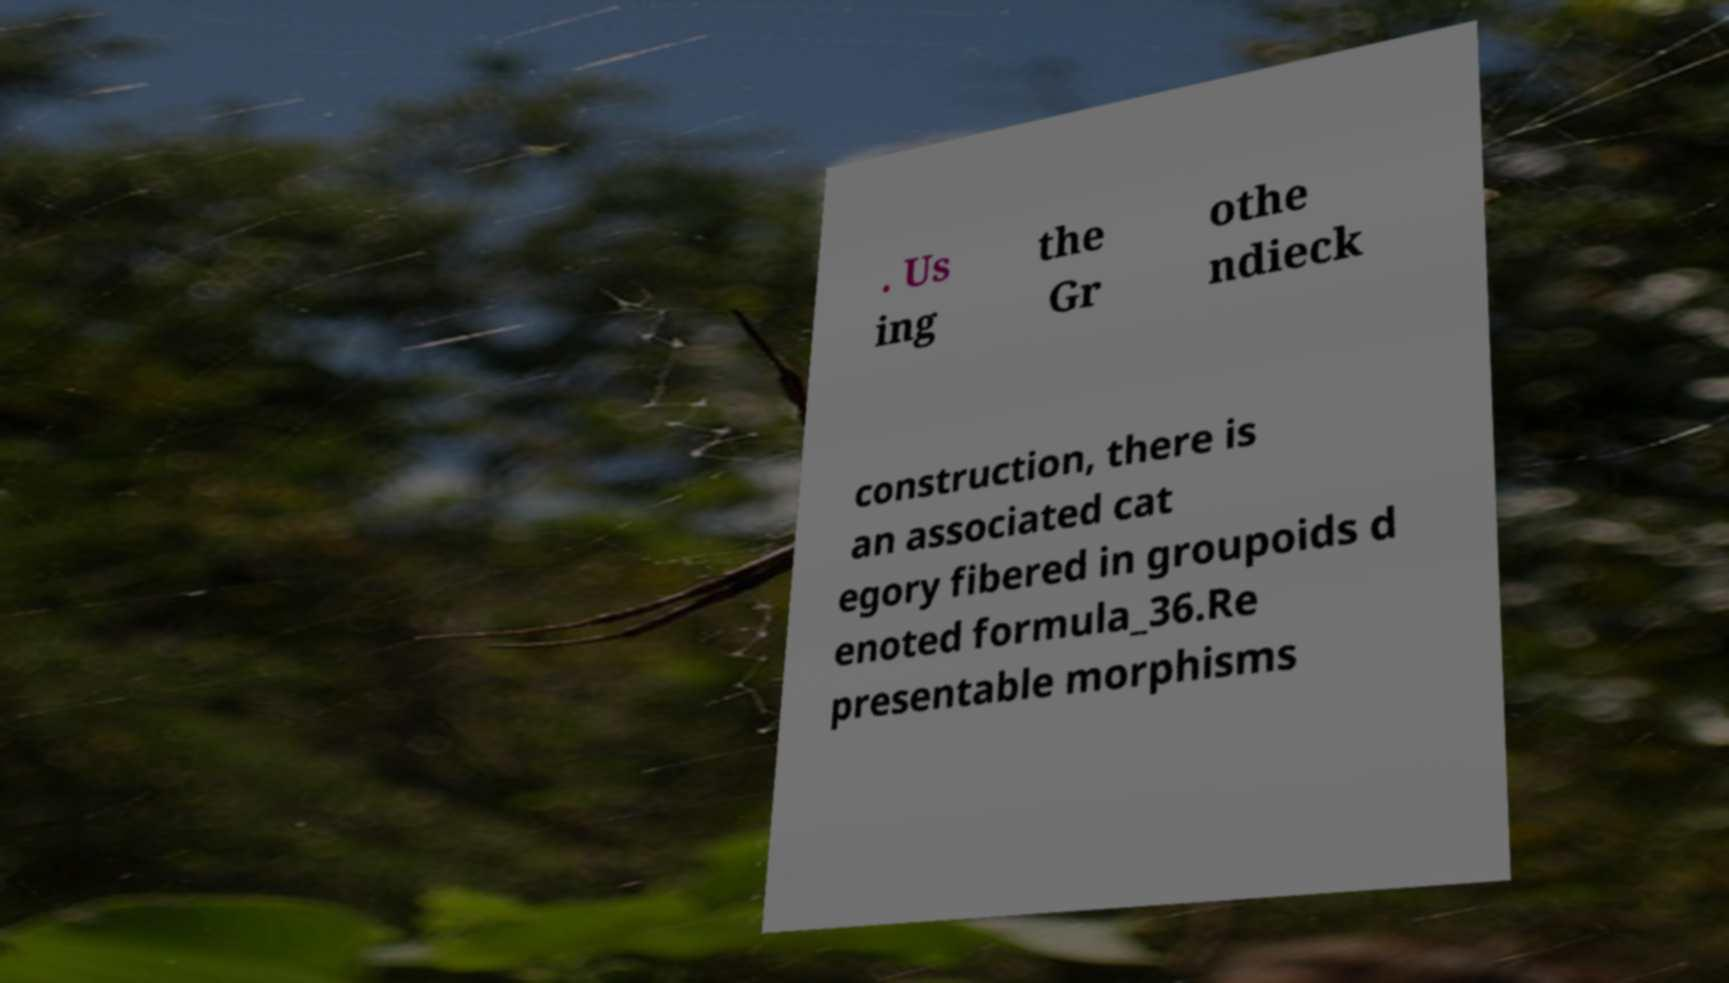Can you accurately transcribe the text from the provided image for me? . Us ing the Gr othe ndieck construction, there is an associated cat egory fibered in groupoids d enoted formula_36.Re presentable morphisms 